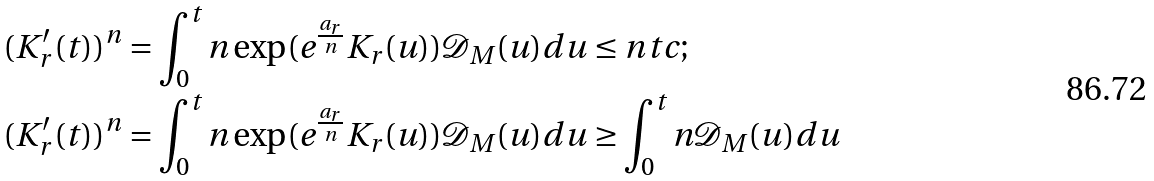<formula> <loc_0><loc_0><loc_500><loc_500>( K ^ { \prime } _ { r } ( t ) ) ^ { n } & = \int _ { 0 } ^ { t } n \exp ( e ^ { \frac { a _ { r } } { n } } { K _ { r } ( u ) } ) \mathcal { D } _ { M } ( u ) d u \leq n t c ; \\ ( K ^ { \prime } _ { r } ( t ) ) ^ { n } & = \int _ { 0 } ^ { t } n \exp ( e ^ { \frac { a _ { r } } { n } } { K _ { r } ( u ) } ) \mathcal { D } _ { M } ( u ) d u \geq \int _ { 0 } ^ { t } n \mathcal { D } _ { M } ( u ) d u</formula> 